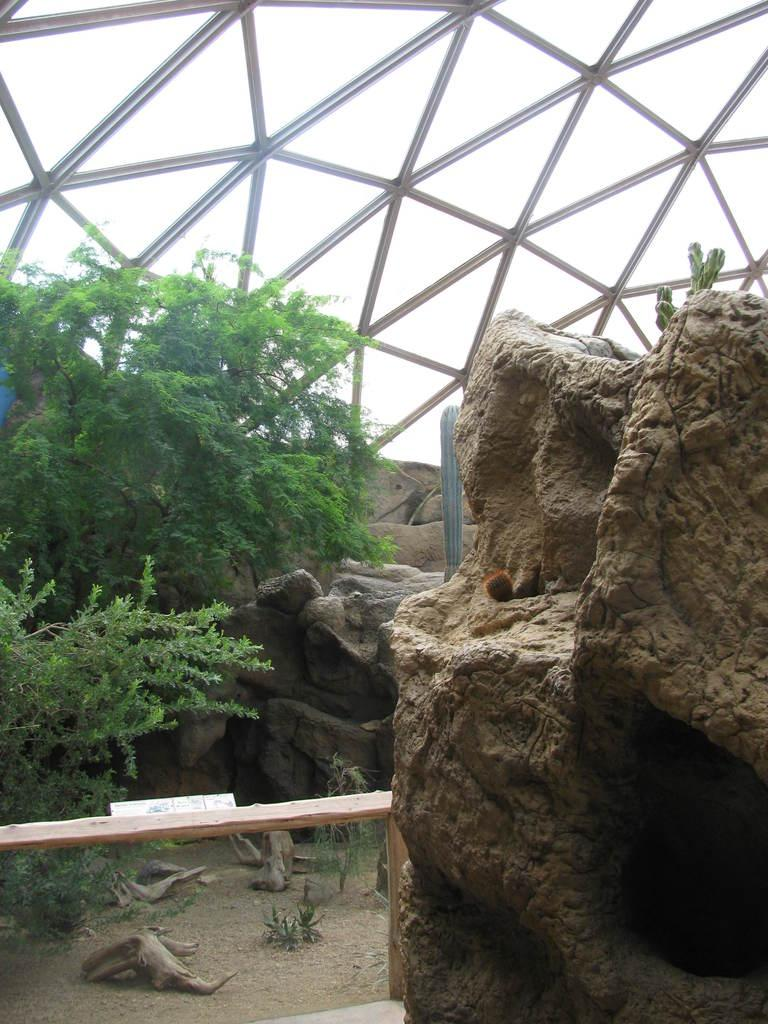What type of natural feature can be seen on the right side of the image? There are rocks on the right side of the image. What type of plant is on the left side of the image? There is a bamboo on the left side of the image. What can be seen in the background of the image? There are trees and trunks in the background of the image. What structure is visible in the background of the image? There is a roof in the background of the image. Can you tell me how many people are rolling a bomb in the image? There are no people or bombs present in the image. What type of creature is shown interacting with the bamboo on the left side of the image? There is no creature shown interacting with the bamboo on the left side of the image; only the bamboo is present. 